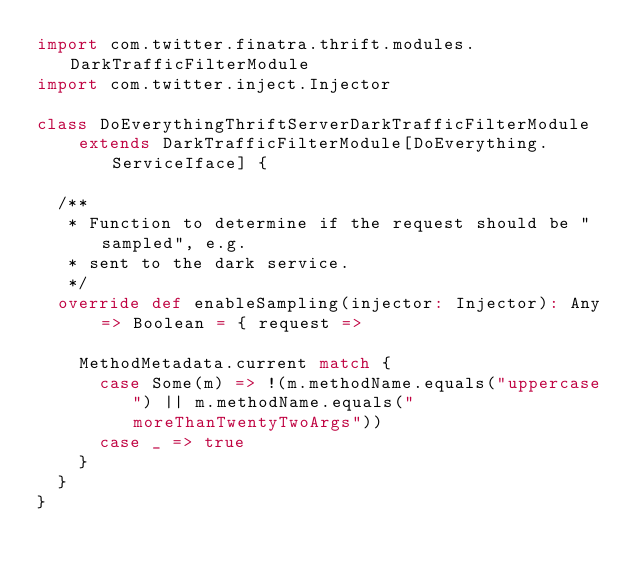<code> <loc_0><loc_0><loc_500><loc_500><_Scala_>import com.twitter.finatra.thrift.modules.DarkTrafficFilterModule
import com.twitter.inject.Injector

class DoEverythingThriftServerDarkTrafficFilterModule
    extends DarkTrafficFilterModule[DoEverything.ServiceIface] {

  /**
   * Function to determine if the request should be "sampled", e.g.
   * sent to the dark service.
   */
  override def enableSampling(injector: Injector): Any => Boolean = { request =>

    MethodMetadata.current match {
      case Some(m) => !(m.methodName.equals("uppercase") || m.methodName.equals("moreThanTwentyTwoArgs"))
      case _ => true
    }
  }
}
</code> 